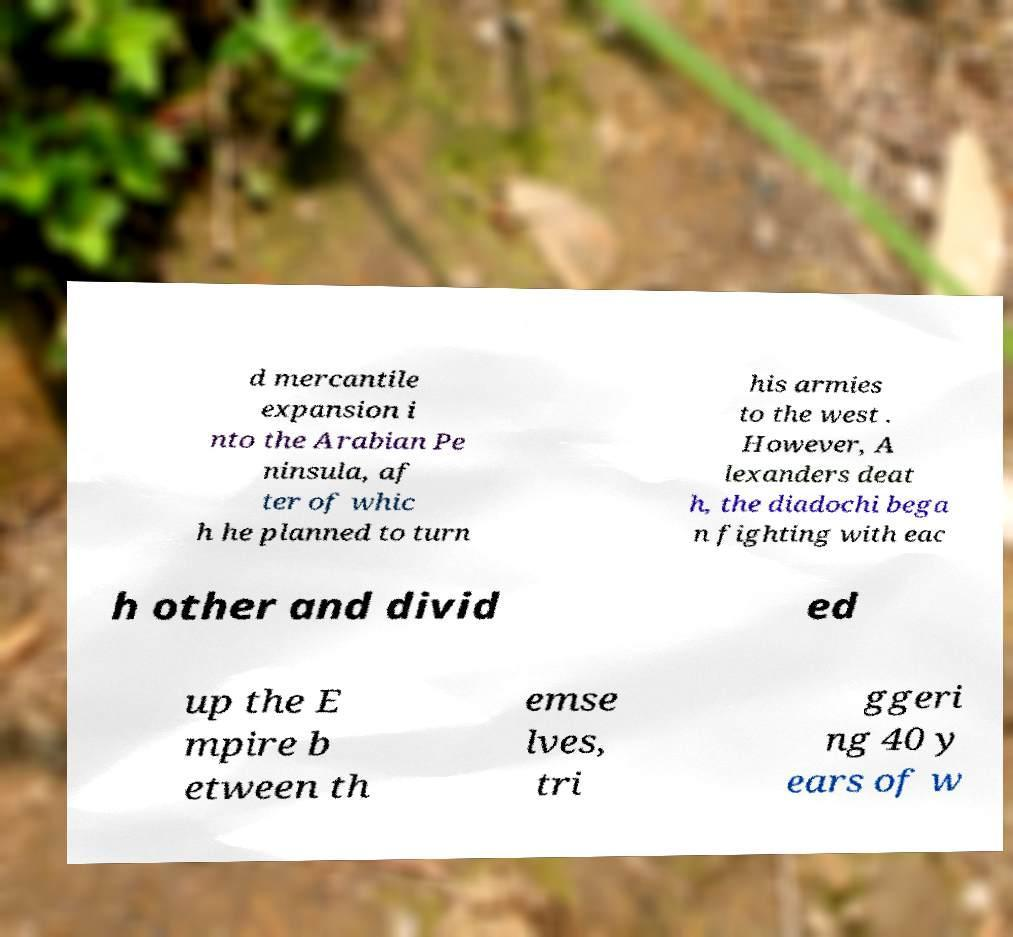Could you assist in decoding the text presented in this image and type it out clearly? d mercantile expansion i nto the Arabian Pe ninsula, af ter of whic h he planned to turn his armies to the west . However, A lexanders deat h, the diadochi bega n fighting with eac h other and divid ed up the E mpire b etween th emse lves, tri ggeri ng 40 y ears of w 